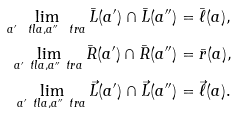<formula> <loc_0><loc_0><loc_500><loc_500>\lim _ { a ^ { \prime } \ t l a , a ^ { \prime \prime } \ t r a } \bar { L } ( a ^ { \prime } ) \cap \bar { L } ( a ^ { \prime \prime } ) & = \bar { \ell } ( a ) , \\ \lim _ { a ^ { \prime } \ t l a , a ^ { \prime \prime } \ t r a } \bar { R } ( a ^ { \prime } ) \cap \bar { R } ( a ^ { \prime \prime } ) & = \bar { r } ( a ) , \\ \lim _ { a ^ { \prime } \ t l a , a ^ { \prime \prime } \ t r a } \vec { L } ( a ^ { \prime } ) \cap \vec { L } ( a ^ { \prime \prime } ) & = \vec { \ell } ( a ) .</formula> 